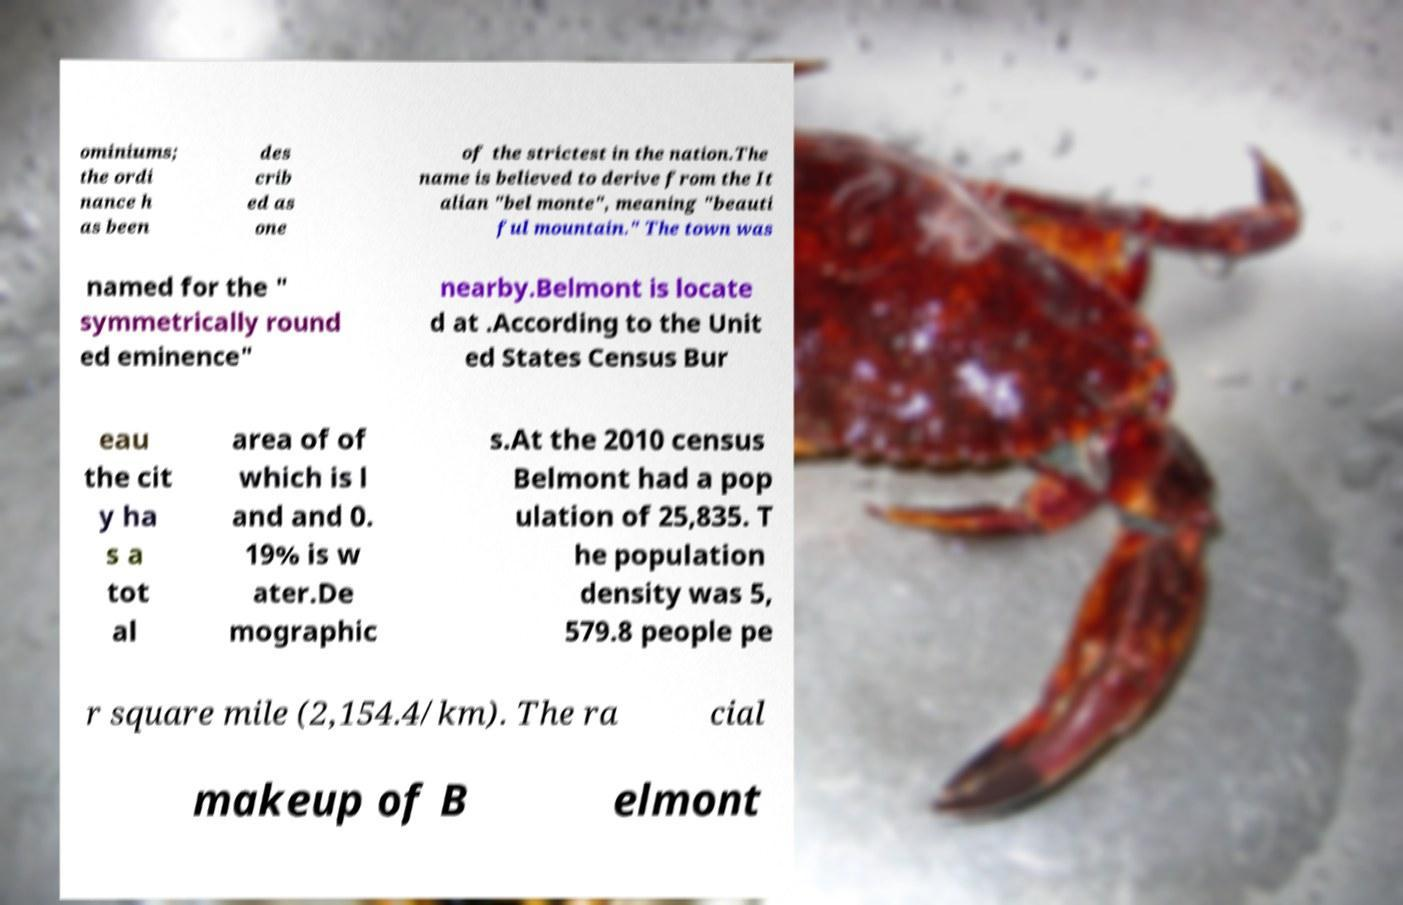Please identify and transcribe the text found in this image. ominiums; the ordi nance h as been des crib ed as one of the strictest in the nation.The name is believed to derive from the It alian "bel monte", meaning "beauti ful mountain." The town was named for the " symmetrically round ed eminence" nearby.Belmont is locate d at .According to the Unit ed States Census Bur eau the cit y ha s a tot al area of of which is l and and 0. 19% is w ater.De mographic s.At the 2010 census Belmont had a pop ulation of 25,835. T he population density was 5, 579.8 people pe r square mile (2,154.4/km). The ra cial makeup of B elmont 